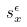Convert formula to latex. <formula><loc_0><loc_0><loc_500><loc_500>s _ { x } ^ { \epsilon }</formula> 